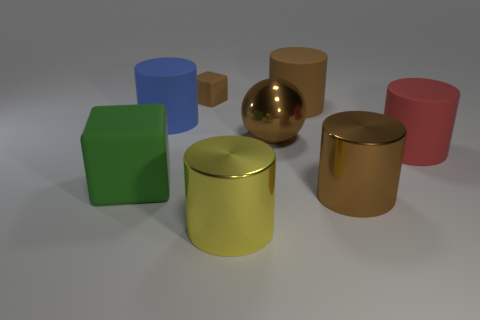Subtract all brown cylinders. How many cylinders are left? 3 Subtract 2 cubes. How many cubes are left? 0 Add 8 big blue spheres. How many big blue spheres exist? 8 Add 2 small brown rubber objects. How many objects exist? 10 Subtract all brown cubes. How many cubes are left? 1 Subtract 1 green cubes. How many objects are left? 7 Subtract all cylinders. How many objects are left? 3 Subtract all brown blocks. Subtract all yellow cylinders. How many blocks are left? 1 Subtract all purple cubes. How many purple cylinders are left? 0 Subtract all big yellow metallic objects. Subtract all big blue cylinders. How many objects are left? 6 